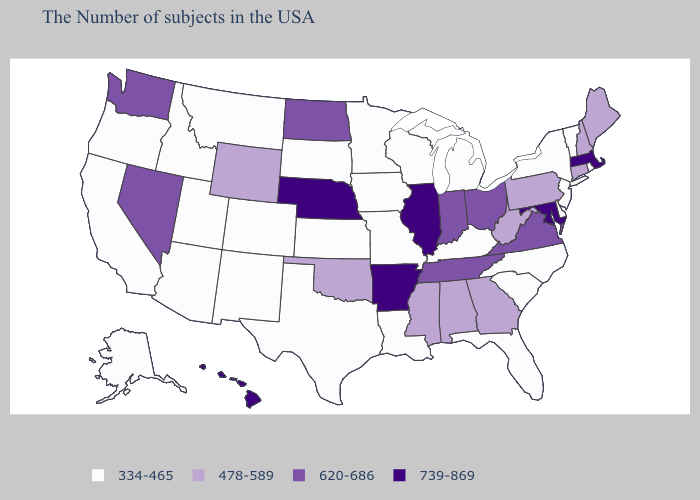What is the value of Washington?
Concise answer only. 620-686. Does Michigan have the highest value in the USA?
Be succinct. No. Name the states that have a value in the range 478-589?
Give a very brief answer. Maine, New Hampshire, Connecticut, Pennsylvania, West Virginia, Georgia, Alabama, Mississippi, Oklahoma, Wyoming. Name the states that have a value in the range 620-686?
Concise answer only. Virginia, Ohio, Indiana, Tennessee, North Dakota, Nevada, Washington. What is the value of Utah?
Keep it brief. 334-465. Which states have the lowest value in the USA?
Answer briefly. Rhode Island, Vermont, New York, New Jersey, Delaware, North Carolina, South Carolina, Florida, Michigan, Kentucky, Wisconsin, Louisiana, Missouri, Minnesota, Iowa, Kansas, Texas, South Dakota, Colorado, New Mexico, Utah, Montana, Arizona, Idaho, California, Oregon, Alaska. Name the states that have a value in the range 739-869?
Be succinct. Massachusetts, Maryland, Illinois, Arkansas, Nebraska, Hawaii. What is the highest value in the South ?
Give a very brief answer. 739-869. Name the states that have a value in the range 478-589?
Keep it brief. Maine, New Hampshire, Connecticut, Pennsylvania, West Virginia, Georgia, Alabama, Mississippi, Oklahoma, Wyoming. What is the value of Washington?
Keep it brief. 620-686. What is the lowest value in states that border Iowa?
Quick response, please. 334-465. What is the value of Vermont?
Quick response, please. 334-465. What is the highest value in the Northeast ?
Concise answer only. 739-869. What is the lowest value in states that border Delaware?
Write a very short answer. 334-465. Which states have the lowest value in the USA?
Write a very short answer. Rhode Island, Vermont, New York, New Jersey, Delaware, North Carolina, South Carolina, Florida, Michigan, Kentucky, Wisconsin, Louisiana, Missouri, Minnesota, Iowa, Kansas, Texas, South Dakota, Colorado, New Mexico, Utah, Montana, Arizona, Idaho, California, Oregon, Alaska. 